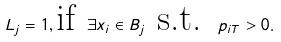<formula> <loc_0><loc_0><loc_500><loc_500>L _ { j } = 1 , \text {if } \exists x _ { i } \in B _ { j } \text { s.t. } p _ { i T } > 0 .</formula> 